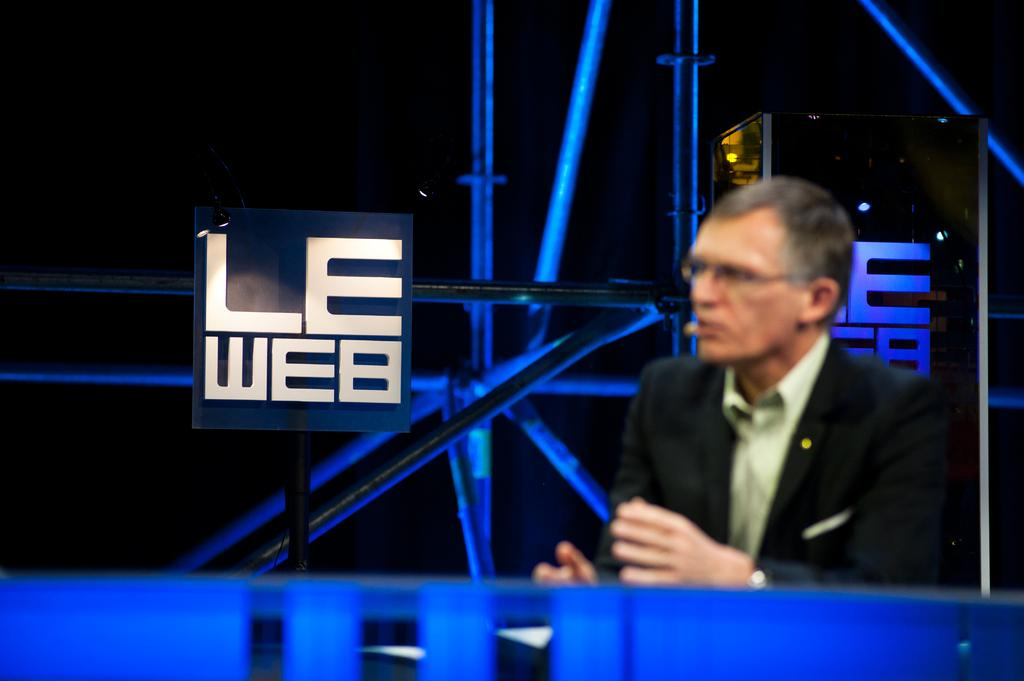<image>
Render a clear and concise summary of the photo. A man speaks in front of a sign that says LE Web. 